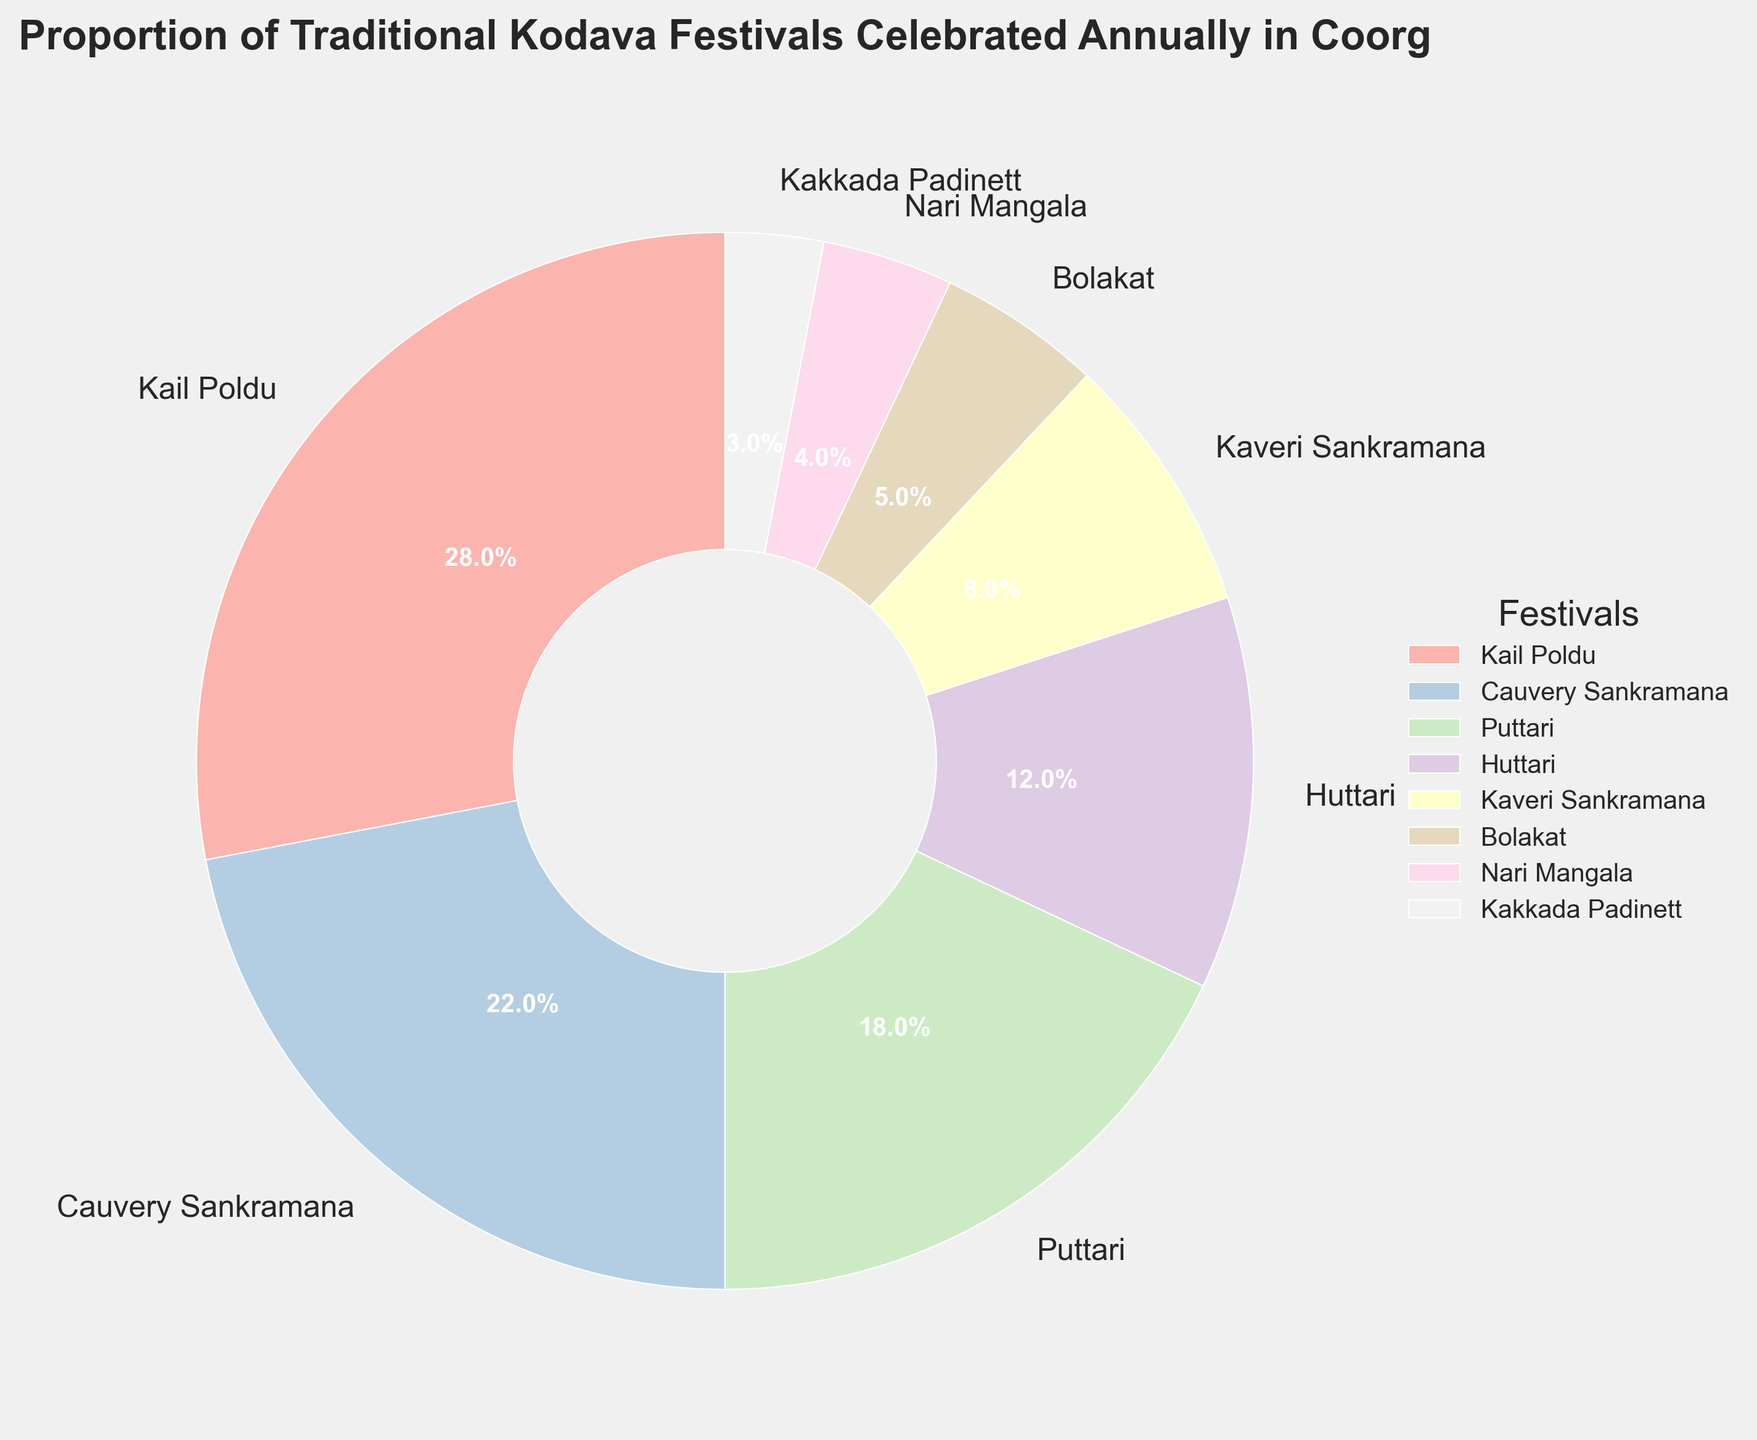What percentage of the total does Kail Poldu contribute? Directly refer to the pie chart slice labeled "Kail Poldu" and read its percentage.
Answer: 28% Which festival has the least representation? Look for the smallest slice in the pie chart and find its label.
Answer: Kakkada Padinett What is the combined percentage of Puttari and Huttari? Add the percentages of Puttari (18%) and Huttari (12%). So, 18 + 12 = 30.
Answer: 30% How many festivals represent less than 10% of the total each? Identify the slices with percentages less than 10%: Kaveri Sankramana (8%), Bolakat (5%), Nari Mangala (4%), Kakkada Padinett (3%). Count them: 4.
Answer: 4 Which festival has a higher percentage, Cauvery Sankramana or Puttari? Compare the percentages of Cauvery Sankramana (22%) and Puttari (18%).
Answer: Cauvery Sankramana What is the total percentage represented by the three smallest festivals? Add the percentages of Kakkada Padinett (3%), Nari Mangala (4%), and Bolakat (5%). So, 3 + 4 + 5 = 12.
Answer: 12% Does Kail Poldu represent more than twice the percentage of Kaveri Sankramana? Compare twice the percentage of Kaveri Sankramana (2 * 8 = 16) with the percentage of Kail Poldu (28). Since 28 > 16, the answer is yes.
Answer: Yes Which festival slices are visually most similar in size? Identify the slices with close percentages, i.e., Huttari (12%) and Kaveri Sankramana (8%).
Answer: Huttari and Kaveri Sankramana 